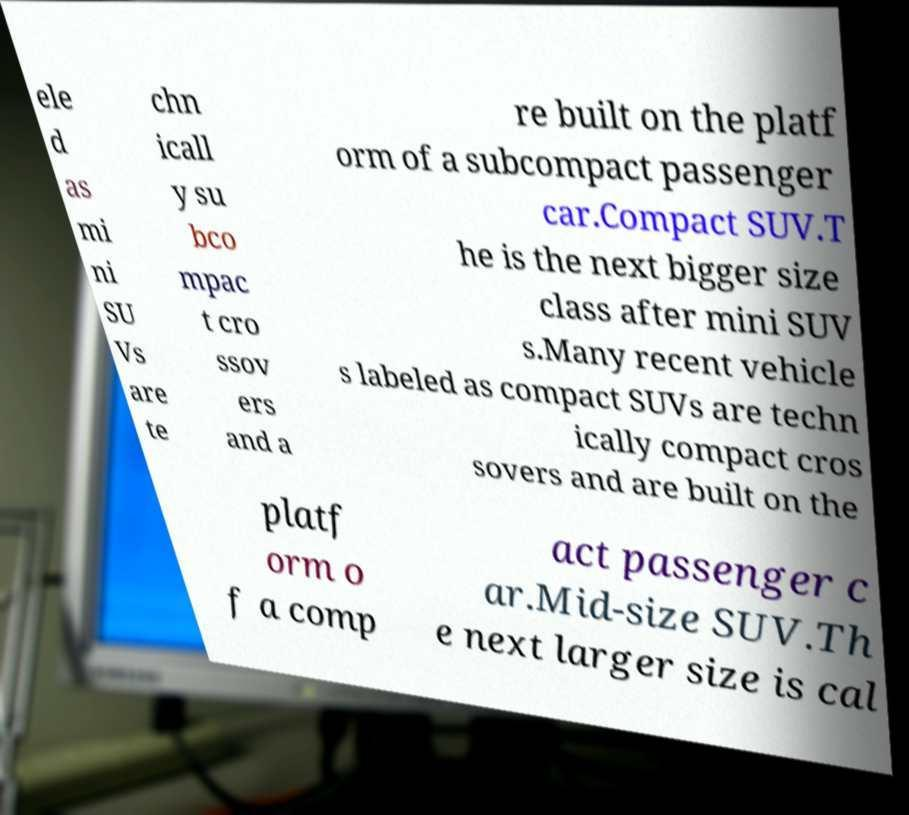Can you read and provide the text displayed in the image?This photo seems to have some interesting text. Can you extract and type it out for me? ele d as mi ni SU Vs are te chn icall y su bco mpac t cro ssov ers and a re built on the platf orm of a subcompact passenger car.Compact SUV.T he is the next bigger size class after mini SUV s.Many recent vehicle s labeled as compact SUVs are techn ically compact cros sovers and are built on the platf orm o f a comp act passenger c ar.Mid-size SUV.Th e next larger size is cal 